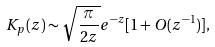<formula> <loc_0><loc_0><loc_500><loc_500>K _ { p } ( z ) \sim \sqrt { \frac { \pi } { 2 z } } e ^ { - z } [ 1 + O ( z ^ { - 1 } ) ] ,</formula> 